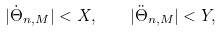<formula> <loc_0><loc_0><loc_500><loc_500>| \dot { \Theta } _ { n , M } | < X , \quad | \ddot { \Theta } _ { n , M } | < Y ,</formula> 